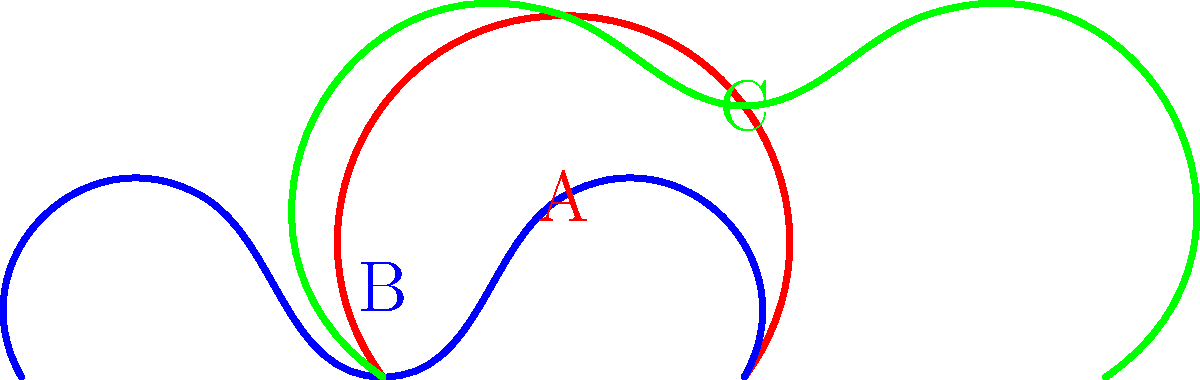Based on the shapes of ancient Greek pottery shown in the diagram, which vessel was primarily used for mixing wine and water during symposia (drinking parties)? To answer this question, let's analyze each shape and its typical function in ancient Greek society:

1. Shape A (red): This is an amphora, typically used for storing and transporting wine or olive oil. It has a narrow neck and two handles.

2. Shape B (blue): This is a kylix, a shallow drinking cup with two handles, used for consuming wine during symposia.

3. Shape C (green): This is a hydria, characterized by its three handles (two horizontal for lifting, one vertical for pouring). It was primarily used for carrying and pouring water.

The vessel used for mixing wine and water during symposia was called a krater. While not shown in this diagram, the closest shape to a krater would be the kylix (Shape B). Although the kylix itself was not used for mixing, it was the vessel most closely associated with wine consumption during symposia.

The correct answer is the kylix (Shape B), as it is the vessel most directly related to wine consumption during symposia, even though it was used for drinking rather than mixing.
Answer: Kylix (Shape B) 